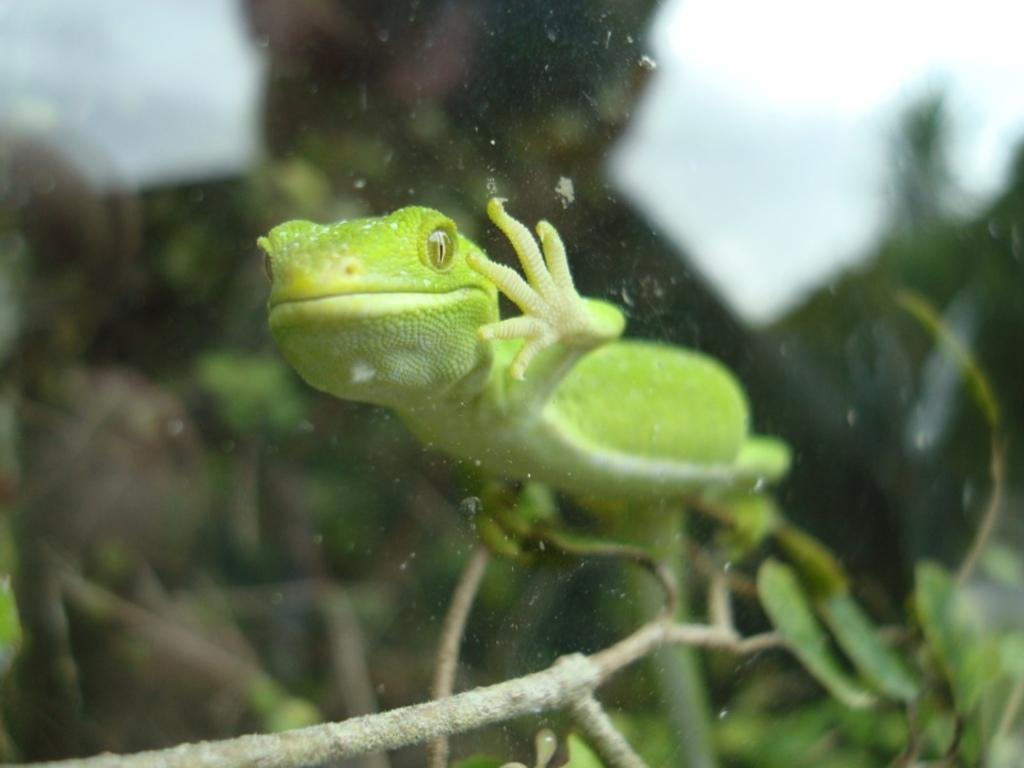What type of living organism can be seen in the image? There is an animal in the image. Where is the animal located in the image? The animal is on a plant. What time of day is depicted in the image? The time of day is not mentioned or depicted in the image, as it only shows an animal on a plant. Is the plant low to the ground or high up in the image? The height of the plant in relation to the ground is not mentioned or depicted in the image, as it only shows an animal on a plant. 